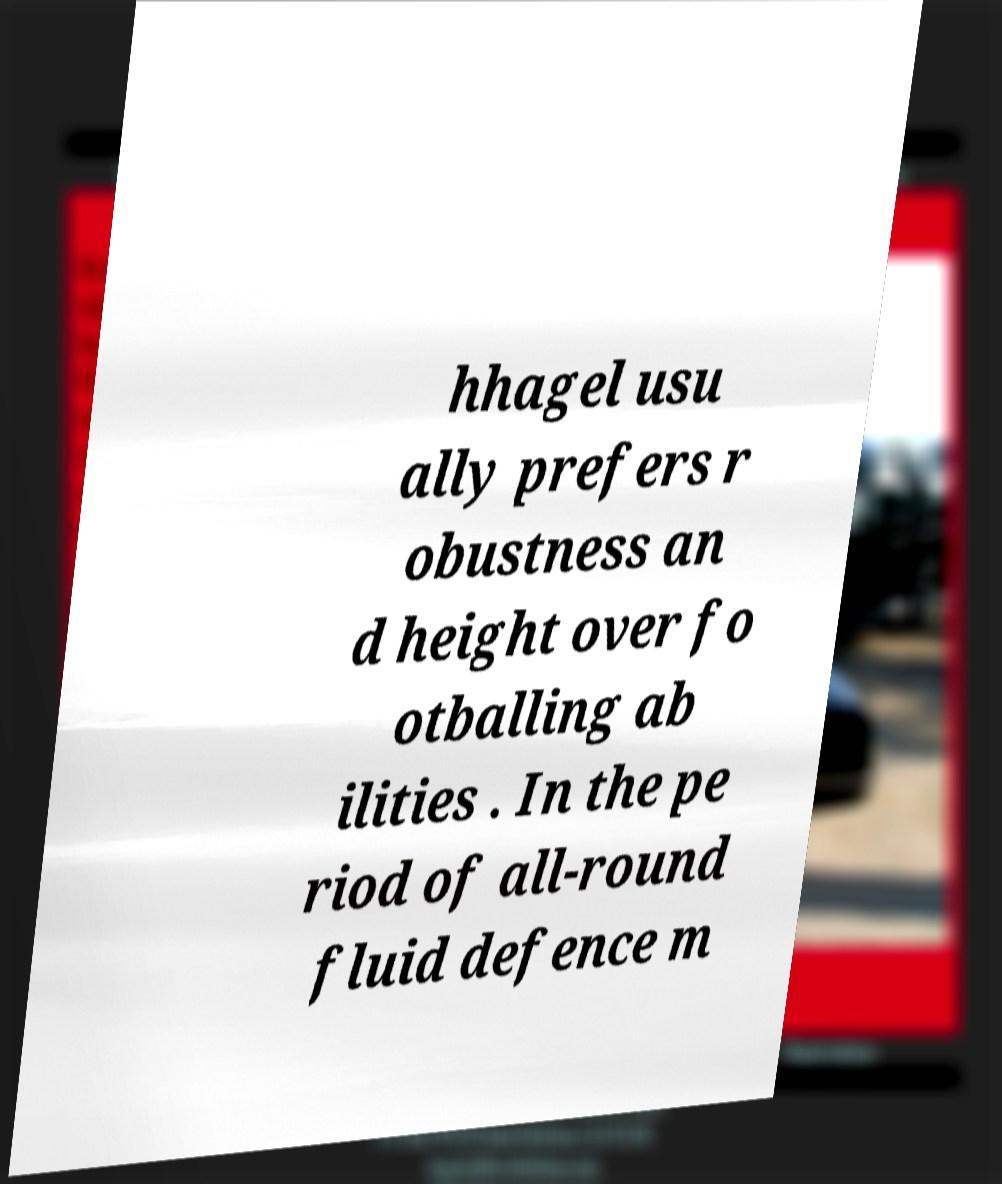What messages or text are displayed in this image? I need them in a readable, typed format. hhagel usu ally prefers r obustness an d height over fo otballing ab ilities . In the pe riod of all-round fluid defence m 